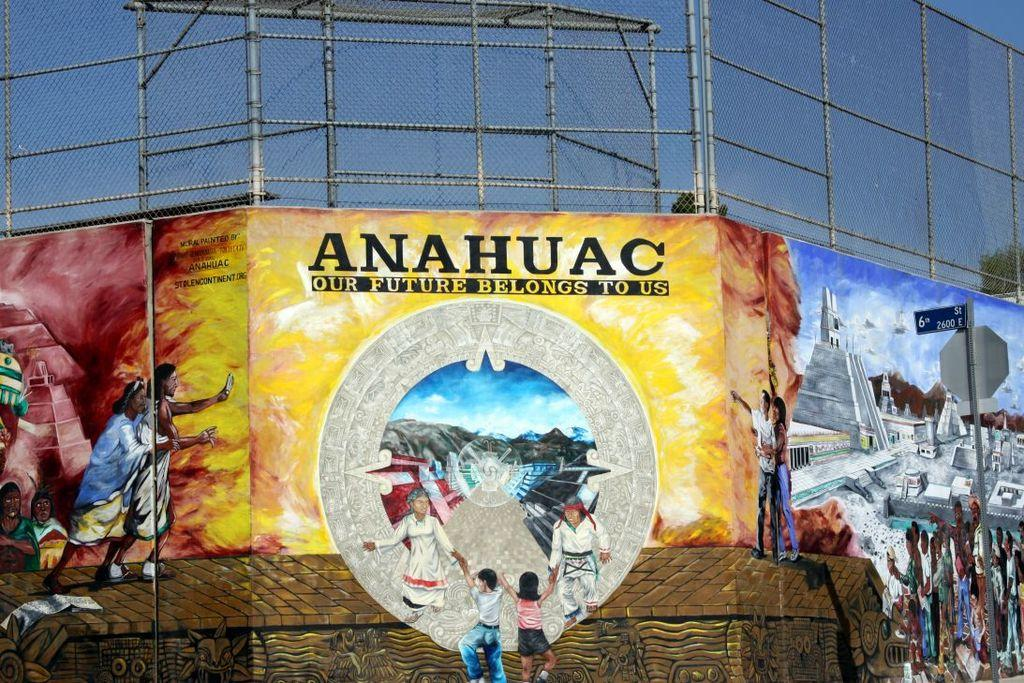<image>
Provide a brief description of the given image. A large yellow poster with a drawing of people on a emblem with the words Anahuac our future belongs to us on the poster. 